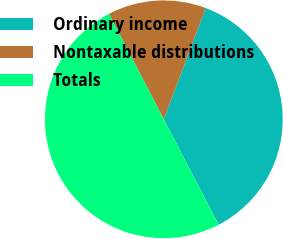<chart> <loc_0><loc_0><loc_500><loc_500><pie_chart><fcel>Ordinary income<fcel>Nontaxable distributions<fcel>Totals<nl><fcel>36.63%<fcel>13.37%<fcel>50.0%<nl></chart> 